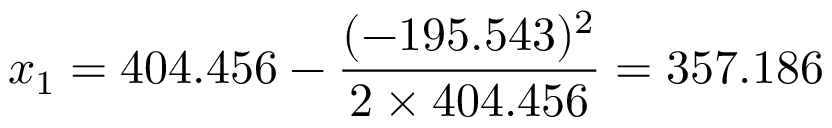Convert formula to latex. <formula><loc_0><loc_0><loc_500><loc_500>x _ { 1 } = 4 0 4 . 4 5 6 - { \frac { ( - 1 9 5 . 5 4 3 ) ^ { 2 } } { 2 \times 4 0 4 . 4 5 6 } } = 3 5 7 . 1 8 6</formula> 